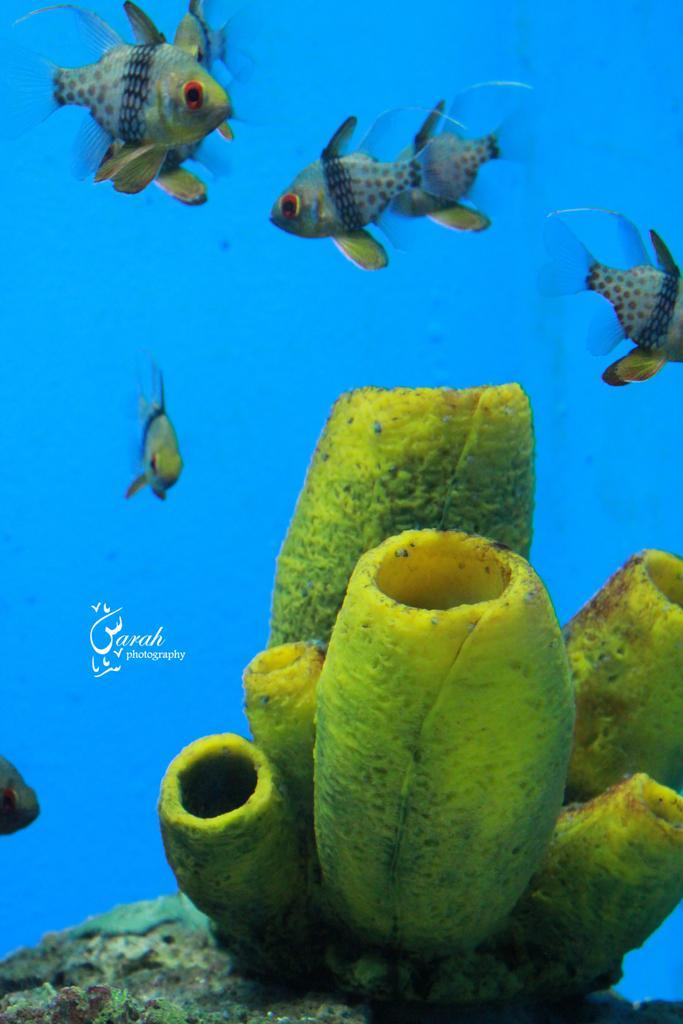Can you describe this image briefly? This picture is taken under the water. I can see few fishes. It is looking like a plant. There is some text on the image. 